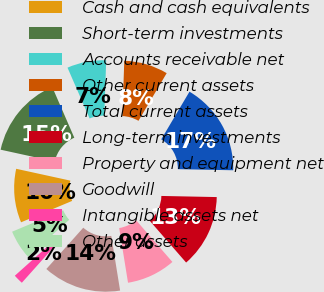Convert chart. <chart><loc_0><loc_0><loc_500><loc_500><pie_chart><fcel>Cash and cash equivalents<fcel>Short-term investments<fcel>Accounts receivable net<fcel>Other current assets<fcel>Total current assets<fcel>Long-term investments<fcel>Property and equipment net<fcel>Goodwill<fcel>Intangible assets net<fcel>Other assets<nl><fcel>9.73%<fcel>15.04%<fcel>7.08%<fcel>7.96%<fcel>16.81%<fcel>13.27%<fcel>8.85%<fcel>14.16%<fcel>1.77%<fcel>5.31%<nl></chart> 